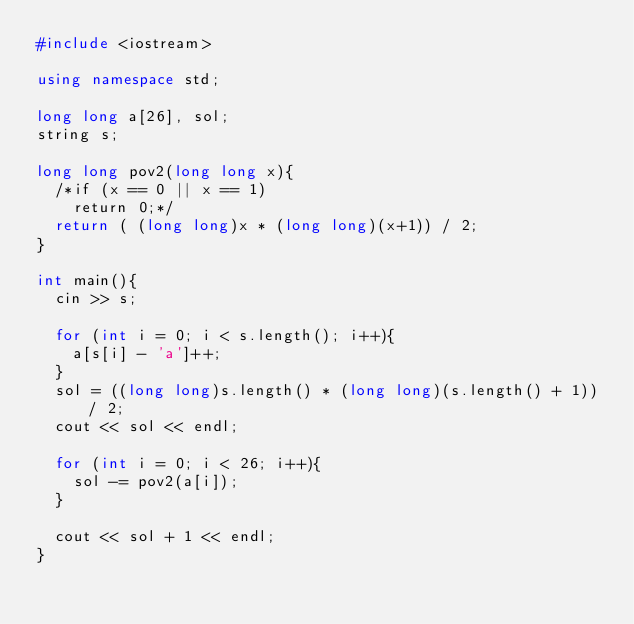<code> <loc_0><loc_0><loc_500><loc_500><_C++_>#include <iostream>

using namespace std;

long long a[26], sol;
string s;

long long pov2(long long x){
  /*if (x == 0 || x == 1)
    return 0;*/
  return ( (long long)x * (long long)(x+1)) / 2;
}

int main(){
  cin >> s;

  for (int i = 0; i < s.length(); i++){
    a[s[i] - 'a']++;
  }
  sol = ((long long)s.length() * (long long)(s.length() + 1)) / 2;
  cout << sol << endl;

  for (int i = 0; i < 26; i++){
    sol -= pov2(a[i]);
  }

  cout << sol + 1 << endl;
}
</code> 